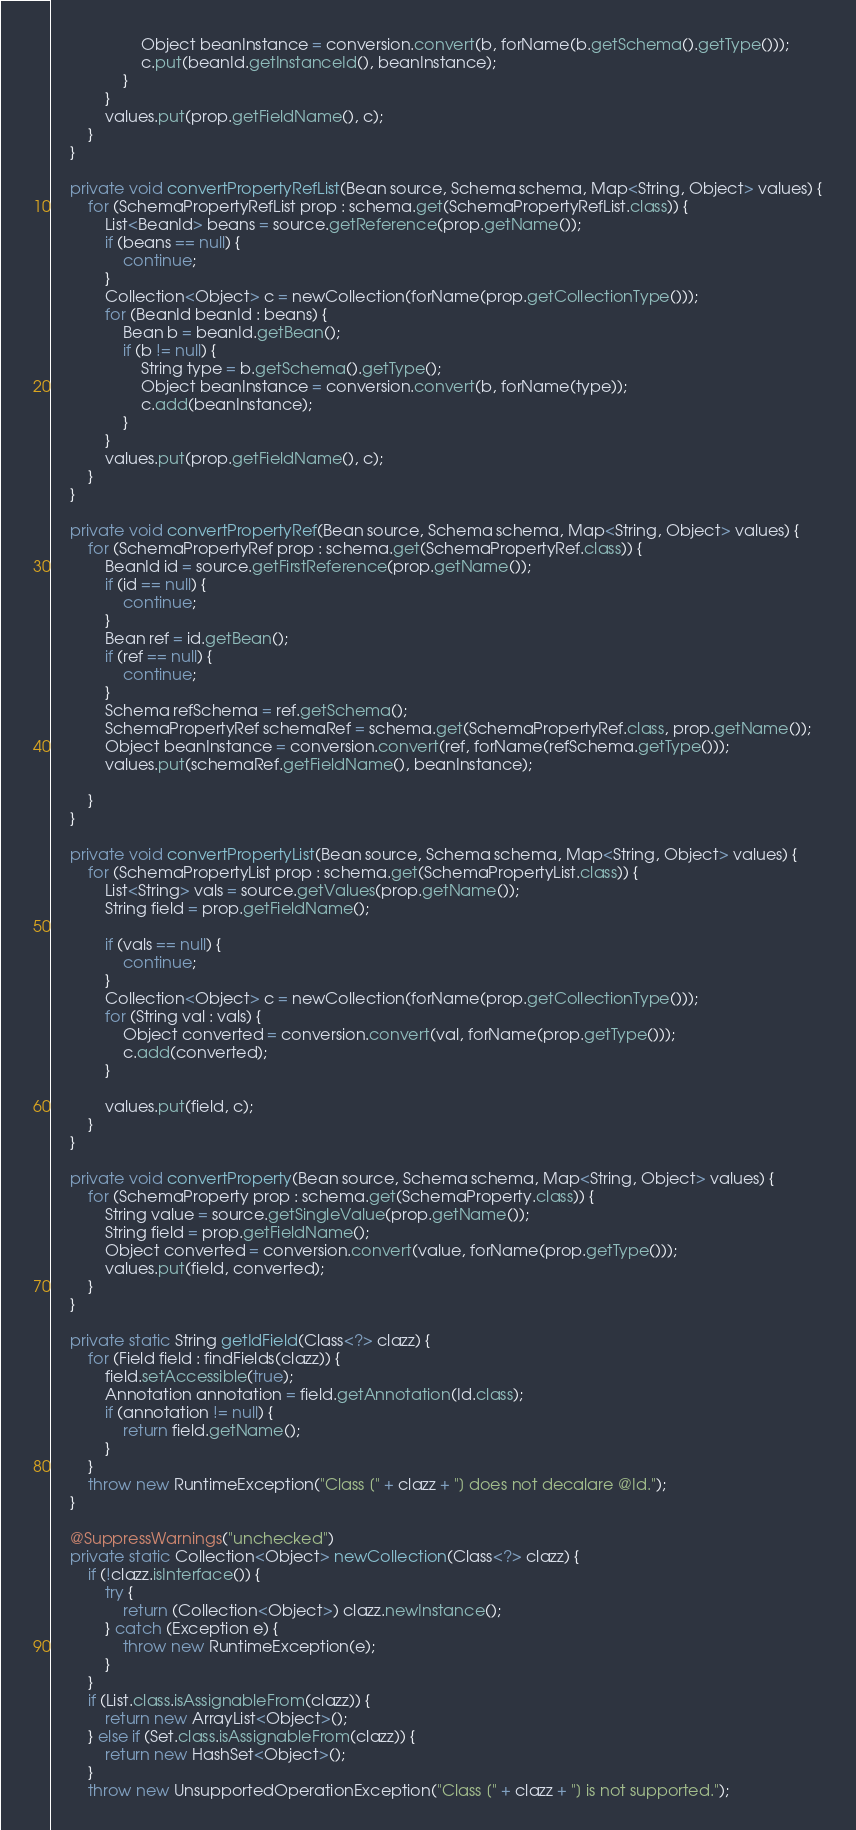<code> <loc_0><loc_0><loc_500><loc_500><_Java_>                    Object beanInstance = conversion.convert(b, forName(b.getSchema().getType()));
                    c.put(beanId.getInstanceId(), beanInstance);
                }
            }
            values.put(prop.getFieldName(), c);
        }
    }

    private void convertPropertyRefList(Bean source, Schema schema, Map<String, Object> values) {
        for (SchemaPropertyRefList prop : schema.get(SchemaPropertyRefList.class)) {
            List<BeanId> beans = source.getReference(prop.getName());
            if (beans == null) {
                continue;
            }
            Collection<Object> c = newCollection(forName(prop.getCollectionType()));
            for (BeanId beanId : beans) {
                Bean b = beanId.getBean();
                if (b != null) {
                    String type = b.getSchema().getType();
                    Object beanInstance = conversion.convert(b, forName(type));
                    c.add(beanInstance);
                }
            }
            values.put(prop.getFieldName(), c);
        }
    }

    private void convertPropertyRef(Bean source, Schema schema, Map<String, Object> values) {
        for (SchemaPropertyRef prop : schema.get(SchemaPropertyRef.class)) {
            BeanId id = source.getFirstReference(prop.getName());
            if (id == null) {
                continue;
            }
            Bean ref = id.getBean();
            if (ref == null) {
                continue;
            }
            Schema refSchema = ref.getSchema();
            SchemaPropertyRef schemaRef = schema.get(SchemaPropertyRef.class, prop.getName());
            Object beanInstance = conversion.convert(ref, forName(refSchema.getType()));
            values.put(schemaRef.getFieldName(), beanInstance);

        }
    }

    private void convertPropertyList(Bean source, Schema schema, Map<String, Object> values) {
        for (SchemaPropertyList prop : schema.get(SchemaPropertyList.class)) {
            List<String> vals = source.getValues(prop.getName());
            String field = prop.getFieldName();

            if (vals == null) {
                continue;
            }
            Collection<Object> c = newCollection(forName(prop.getCollectionType()));
            for (String val : vals) {
                Object converted = conversion.convert(val, forName(prop.getType()));
                c.add(converted);
            }

            values.put(field, c);
        }
    }

    private void convertProperty(Bean source, Schema schema, Map<String, Object> values) {
        for (SchemaProperty prop : schema.get(SchemaProperty.class)) {
            String value = source.getSingleValue(prop.getName());
            String field = prop.getFieldName();
            Object converted = conversion.convert(value, forName(prop.getType()));
            values.put(field, converted);
        }
    }

    private static String getIdField(Class<?> clazz) {
        for (Field field : findFields(clazz)) {
            field.setAccessible(true);
            Annotation annotation = field.getAnnotation(Id.class);
            if (annotation != null) {
                return field.getName();
            }
        }
        throw new RuntimeException("Class [" + clazz + "] does not decalare @Id.");
    }

    @SuppressWarnings("unchecked")
    private static Collection<Object> newCollection(Class<?> clazz) {
        if (!clazz.isInterface()) {
            try {
                return (Collection<Object>) clazz.newInstance();
            } catch (Exception e) {
                throw new RuntimeException(e);
            }
        }
        if (List.class.isAssignableFrom(clazz)) {
            return new ArrayList<Object>();
        } else if (Set.class.isAssignableFrom(clazz)) {
            return new HashSet<Object>();
        }
        throw new UnsupportedOperationException("Class [" + clazz + "] is not supported.");</code> 